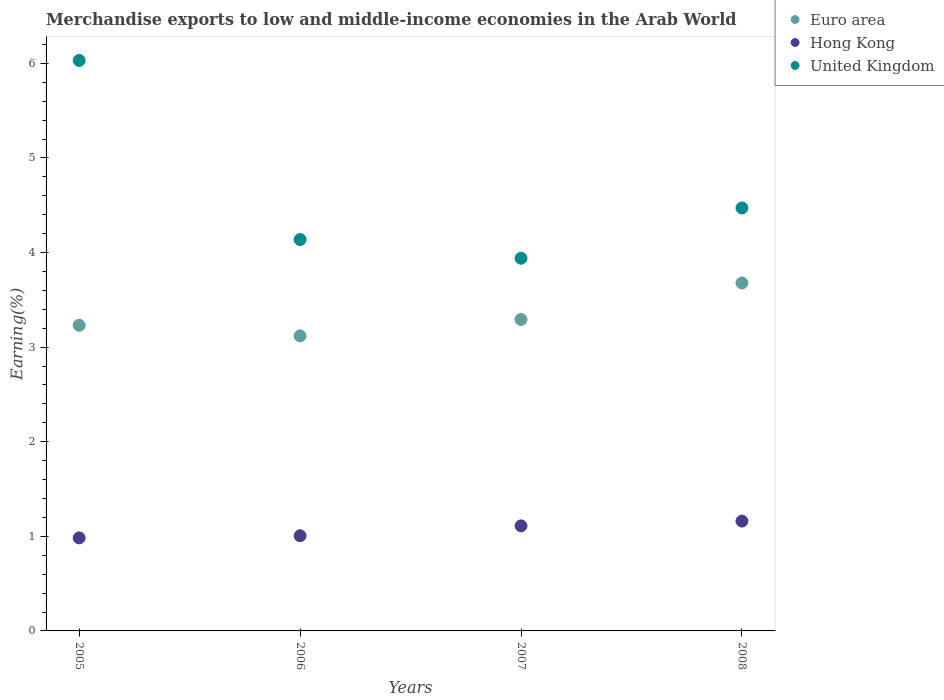How many different coloured dotlines are there?
Your answer should be compact. 3. What is the percentage of amount earned from merchandise exports in Euro area in 2005?
Make the answer very short. 3.23. Across all years, what is the maximum percentage of amount earned from merchandise exports in Hong Kong?
Keep it short and to the point. 1.16. Across all years, what is the minimum percentage of amount earned from merchandise exports in Euro area?
Make the answer very short. 3.12. In which year was the percentage of amount earned from merchandise exports in United Kingdom minimum?
Your response must be concise. 2007. What is the total percentage of amount earned from merchandise exports in Euro area in the graph?
Your response must be concise. 13.32. What is the difference between the percentage of amount earned from merchandise exports in United Kingdom in 2005 and that in 2006?
Offer a very short reply. 1.89. What is the difference between the percentage of amount earned from merchandise exports in Hong Kong in 2007 and the percentage of amount earned from merchandise exports in Euro area in 2008?
Ensure brevity in your answer.  -2.57. What is the average percentage of amount earned from merchandise exports in Euro area per year?
Provide a short and direct response. 3.33. In the year 2005, what is the difference between the percentage of amount earned from merchandise exports in Euro area and percentage of amount earned from merchandise exports in Hong Kong?
Make the answer very short. 2.25. What is the ratio of the percentage of amount earned from merchandise exports in United Kingdom in 2005 to that in 2007?
Give a very brief answer. 1.53. Is the percentage of amount earned from merchandise exports in United Kingdom in 2005 less than that in 2007?
Offer a very short reply. No. What is the difference between the highest and the second highest percentage of amount earned from merchandise exports in United Kingdom?
Your response must be concise. 1.56. What is the difference between the highest and the lowest percentage of amount earned from merchandise exports in Hong Kong?
Keep it short and to the point. 0.18. Is it the case that in every year, the sum of the percentage of amount earned from merchandise exports in United Kingdom and percentage of amount earned from merchandise exports in Hong Kong  is greater than the percentage of amount earned from merchandise exports in Euro area?
Provide a short and direct response. Yes. Does the graph contain grids?
Offer a terse response. No. How many legend labels are there?
Provide a succinct answer. 3. How are the legend labels stacked?
Make the answer very short. Vertical. What is the title of the graph?
Provide a short and direct response. Merchandise exports to low and middle-income economies in the Arab World. What is the label or title of the Y-axis?
Give a very brief answer. Earning(%). What is the Earning(%) in Euro area in 2005?
Your answer should be very brief. 3.23. What is the Earning(%) of Hong Kong in 2005?
Your answer should be compact. 0.98. What is the Earning(%) in United Kingdom in 2005?
Offer a terse response. 6.03. What is the Earning(%) in Euro area in 2006?
Provide a succinct answer. 3.12. What is the Earning(%) in Hong Kong in 2006?
Keep it short and to the point. 1.01. What is the Earning(%) in United Kingdom in 2006?
Give a very brief answer. 4.14. What is the Earning(%) of Euro area in 2007?
Make the answer very short. 3.29. What is the Earning(%) in Hong Kong in 2007?
Your answer should be very brief. 1.11. What is the Earning(%) of United Kingdom in 2007?
Provide a succinct answer. 3.94. What is the Earning(%) in Euro area in 2008?
Give a very brief answer. 3.68. What is the Earning(%) of Hong Kong in 2008?
Make the answer very short. 1.16. What is the Earning(%) of United Kingdom in 2008?
Ensure brevity in your answer.  4.47. Across all years, what is the maximum Earning(%) in Euro area?
Offer a terse response. 3.68. Across all years, what is the maximum Earning(%) in Hong Kong?
Provide a short and direct response. 1.16. Across all years, what is the maximum Earning(%) in United Kingdom?
Offer a terse response. 6.03. Across all years, what is the minimum Earning(%) in Euro area?
Offer a terse response. 3.12. Across all years, what is the minimum Earning(%) of Hong Kong?
Your answer should be very brief. 0.98. Across all years, what is the minimum Earning(%) in United Kingdom?
Offer a terse response. 3.94. What is the total Earning(%) of Euro area in the graph?
Offer a very short reply. 13.32. What is the total Earning(%) of Hong Kong in the graph?
Provide a short and direct response. 4.26. What is the total Earning(%) in United Kingdom in the graph?
Offer a terse response. 18.58. What is the difference between the Earning(%) of Euro area in 2005 and that in 2006?
Your answer should be compact. 0.11. What is the difference between the Earning(%) of Hong Kong in 2005 and that in 2006?
Provide a short and direct response. -0.02. What is the difference between the Earning(%) of United Kingdom in 2005 and that in 2006?
Your response must be concise. 1.89. What is the difference between the Earning(%) in Euro area in 2005 and that in 2007?
Your answer should be compact. -0.06. What is the difference between the Earning(%) of Hong Kong in 2005 and that in 2007?
Make the answer very short. -0.13. What is the difference between the Earning(%) in United Kingdom in 2005 and that in 2007?
Provide a short and direct response. 2.09. What is the difference between the Earning(%) in Euro area in 2005 and that in 2008?
Ensure brevity in your answer.  -0.45. What is the difference between the Earning(%) in Hong Kong in 2005 and that in 2008?
Ensure brevity in your answer.  -0.18. What is the difference between the Earning(%) of United Kingdom in 2005 and that in 2008?
Make the answer very short. 1.56. What is the difference between the Earning(%) of Euro area in 2006 and that in 2007?
Your answer should be very brief. -0.17. What is the difference between the Earning(%) of Hong Kong in 2006 and that in 2007?
Offer a terse response. -0.1. What is the difference between the Earning(%) of United Kingdom in 2006 and that in 2007?
Make the answer very short. 0.2. What is the difference between the Earning(%) in Euro area in 2006 and that in 2008?
Ensure brevity in your answer.  -0.56. What is the difference between the Earning(%) in Hong Kong in 2006 and that in 2008?
Offer a terse response. -0.15. What is the difference between the Earning(%) in United Kingdom in 2006 and that in 2008?
Give a very brief answer. -0.33. What is the difference between the Earning(%) in Euro area in 2007 and that in 2008?
Give a very brief answer. -0.39. What is the difference between the Earning(%) in Hong Kong in 2007 and that in 2008?
Provide a succinct answer. -0.05. What is the difference between the Earning(%) in United Kingdom in 2007 and that in 2008?
Your response must be concise. -0.53. What is the difference between the Earning(%) of Euro area in 2005 and the Earning(%) of Hong Kong in 2006?
Offer a terse response. 2.22. What is the difference between the Earning(%) of Euro area in 2005 and the Earning(%) of United Kingdom in 2006?
Offer a terse response. -0.91. What is the difference between the Earning(%) in Hong Kong in 2005 and the Earning(%) in United Kingdom in 2006?
Your answer should be very brief. -3.15. What is the difference between the Earning(%) of Euro area in 2005 and the Earning(%) of Hong Kong in 2007?
Give a very brief answer. 2.12. What is the difference between the Earning(%) of Euro area in 2005 and the Earning(%) of United Kingdom in 2007?
Make the answer very short. -0.71. What is the difference between the Earning(%) of Hong Kong in 2005 and the Earning(%) of United Kingdom in 2007?
Give a very brief answer. -2.96. What is the difference between the Earning(%) in Euro area in 2005 and the Earning(%) in Hong Kong in 2008?
Offer a terse response. 2.07. What is the difference between the Earning(%) of Euro area in 2005 and the Earning(%) of United Kingdom in 2008?
Provide a short and direct response. -1.24. What is the difference between the Earning(%) in Hong Kong in 2005 and the Earning(%) in United Kingdom in 2008?
Provide a short and direct response. -3.49. What is the difference between the Earning(%) in Euro area in 2006 and the Earning(%) in Hong Kong in 2007?
Your response must be concise. 2.01. What is the difference between the Earning(%) of Euro area in 2006 and the Earning(%) of United Kingdom in 2007?
Your response must be concise. -0.82. What is the difference between the Earning(%) of Hong Kong in 2006 and the Earning(%) of United Kingdom in 2007?
Your response must be concise. -2.93. What is the difference between the Earning(%) of Euro area in 2006 and the Earning(%) of Hong Kong in 2008?
Provide a succinct answer. 1.96. What is the difference between the Earning(%) of Euro area in 2006 and the Earning(%) of United Kingdom in 2008?
Provide a succinct answer. -1.35. What is the difference between the Earning(%) in Hong Kong in 2006 and the Earning(%) in United Kingdom in 2008?
Ensure brevity in your answer.  -3.47. What is the difference between the Earning(%) of Euro area in 2007 and the Earning(%) of Hong Kong in 2008?
Ensure brevity in your answer.  2.13. What is the difference between the Earning(%) of Euro area in 2007 and the Earning(%) of United Kingdom in 2008?
Your answer should be compact. -1.18. What is the difference between the Earning(%) of Hong Kong in 2007 and the Earning(%) of United Kingdom in 2008?
Give a very brief answer. -3.36. What is the average Earning(%) of Euro area per year?
Your answer should be compact. 3.33. What is the average Earning(%) in Hong Kong per year?
Provide a succinct answer. 1.07. What is the average Earning(%) of United Kingdom per year?
Provide a succinct answer. 4.65. In the year 2005, what is the difference between the Earning(%) in Euro area and Earning(%) in Hong Kong?
Make the answer very short. 2.25. In the year 2005, what is the difference between the Earning(%) of Euro area and Earning(%) of United Kingdom?
Your response must be concise. -2.8. In the year 2005, what is the difference between the Earning(%) in Hong Kong and Earning(%) in United Kingdom?
Ensure brevity in your answer.  -5.05. In the year 2006, what is the difference between the Earning(%) in Euro area and Earning(%) in Hong Kong?
Make the answer very short. 2.11. In the year 2006, what is the difference between the Earning(%) in Euro area and Earning(%) in United Kingdom?
Your answer should be very brief. -1.02. In the year 2006, what is the difference between the Earning(%) of Hong Kong and Earning(%) of United Kingdom?
Your answer should be very brief. -3.13. In the year 2007, what is the difference between the Earning(%) in Euro area and Earning(%) in Hong Kong?
Keep it short and to the point. 2.18. In the year 2007, what is the difference between the Earning(%) in Euro area and Earning(%) in United Kingdom?
Offer a terse response. -0.65. In the year 2007, what is the difference between the Earning(%) in Hong Kong and Earning(%) in United Kingdom?
Ensure brevity in your answer.  -2.83. In the year 2008, what is the difference between the Earning(%) of Euro area and Earning(%) of Hong Kong?
Offer a terse response. 2.52. In the year 2008, what is the difference between the Earning(%) in Euro area and Earning(%) in United Kingdom?
Ensure brevity in your answer.  -0.79. In the year 2008, what is the difference between the Earning(%) in Hong Kong and Earning(%) in United Kingdom?
Provide a short and direct response. -3.31. What is the ratio of the Earning(%) of Euro area in 2005 to that in 2006?
Ensure brevity in your answer.  1.04. What is the ratio of the Earning(%) in Hong Kong in 2005 to that in 2006?
Offer a terse response. 0.98. What is the ratio of the Earning(%) in United Kingdom in 2005 to that in 2006?
Your response must be concise. 1.46. What is the ratio of the Earning(%) of Euro area in 2005 to that in 2007?
Provide a succinct answer. 0.98. What is the ratio of the Earning(%) of Hong Kong in 2005 to that in 2007?
Your answer should be compact. 0.89. What is the ratio of the Earning(%) of United Kingdom in 2005 to that in 2007?
Your answer should be compact. 1.53. What is the ratio of the Earning(%) in Euro area in 2005 to that in 2008?
Make the answer very short. 0.88. What is the ratio of the Earning(%) in Hong Kong in 2005 to that in 2008?
Make the answer very short. 0.85. What is the ratio of the Earning(%) of United Kingdom in 2005 to that in 2008?
Offer a very short reply. 1.35. What is the ratio of the Earning(%) in Euro area in 2006 to that in 2007?
Your answer should be very brief. 0.95. What is the ratio of the Earning(%) of Hong Kong in 2006 to that in 2007?
Offer a very short reply. 0.91. What is the ratio of the Earning(%) of United Kingdom in 2006 to that in 2007?
Provide a succinct answer. 1.05. What is the ratio of the Earning(%) in Euro area in 2006 to that in 2008?
Provide a short and direct response. 0.85. What is the ratio of the Earning(%) of Hong Kong in 2006 to that in 2008?
Offer a very short reply. 0.87. What is the ratio of the Earning(%) in United Kingdom in 2006 to that in 2008?
Make the answer very short. 0.93. What is the ratio of the Earning(%) in Euro area in 2007 to that in 2008?
Provide a succinct answer. 0.9. What is the ratio of the Earning(%) of Hong Kong in 2007 to that in 2008?
Give a very brief answer. 0.96. What is the ratio of the Earning(%) in United Kingdom in 2007 to that in 2008?
Your answer should be very brief. 0.88. What is the difference between the highest and the second highest Earning(%) in Euro area?
Your answer should be compact. 0.39. What is the difference between the highest and the second highest Earning(%) of Hong Kong?
Provide a short and direct response. 0.05. What is the difference between the highest and the second highest Earning(%) in United Kingdom?
Your answer should be very brief. 1.56. What is the difference between the highest and the lowest Earning(%) in Euro area?
Offer a very short reply. 0.56. What is the difference between the highest and the lowest Earning(%) in Hong Kong?
Offer a very short reply. 0.18. What is the difference between the highest and the lowest Earning(%) of United Kingdom?
Offer a very short reply. 2.09. 